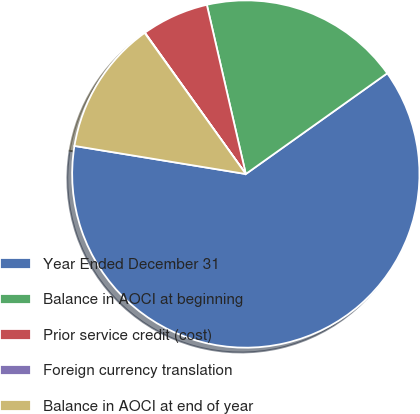Convert chart. <chart><loc_0><loc_0><loc_500><loc_500><pie_chart><fcel>Year Ended December 31<fcel>Balance in AOCI at beginning<fcel>Prior service credit (cost)<fcel>Foreign currency translation<fcel>Balance in AOCI at end of year<nl><fcel>62.43%<fcel>18.75%<fcel>6.27%<fcel>0.03%<fcel>12.51%<nl></chart> 